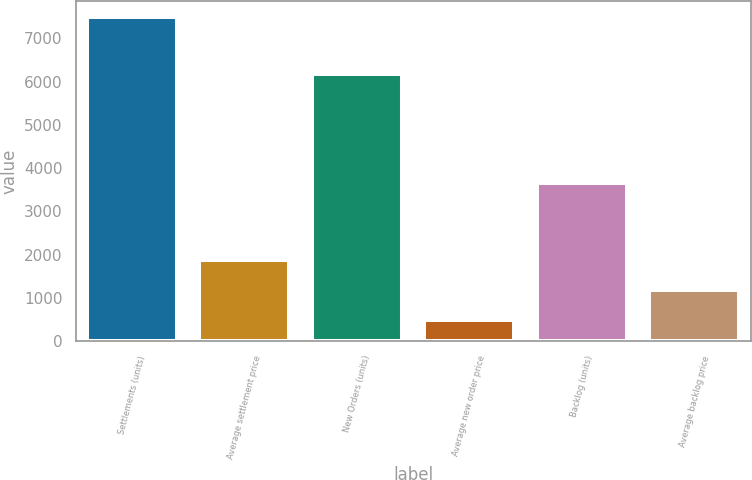Convert chart to OTSL. <chart><loc_0><loc_0><loc_500><loc_500><bar_chart><fcel>Settlements (units)<fcel>Average settlement price<fcel>New Orders (units)<fcel>Average new order price<fcel>Backlog (units)<fcel>Average backlog price<nl><fcel>7491<fcel>1881.88<fcel>6182<fcel>479.6<fcel>3665<fcel>1180.74<nl></chart> 